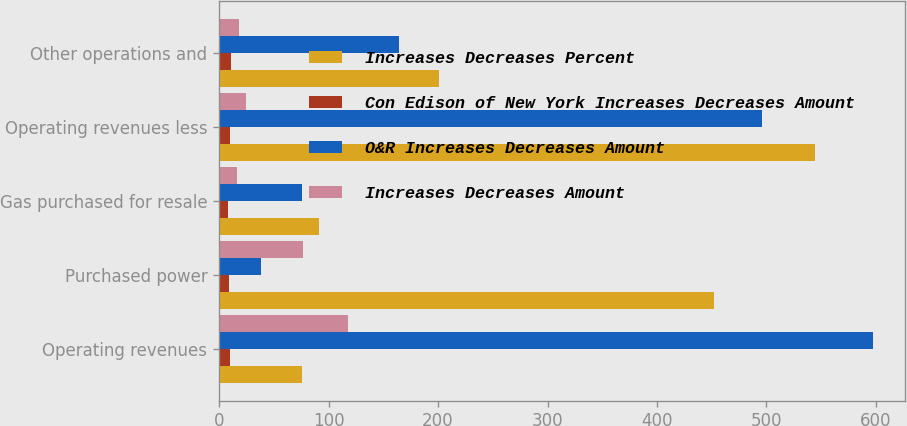<chart> <loc_0><loc_0><loc_500><loc_500><stacked_bar_chart><ecel><fcel>Operating revenues<fcel>Purchased power<fcel>Gas purchased for resale<fcel>Operating revenues less<fcel>Other operations and<nl><fcel>Increases Decreases Percent<fcel>76<fcel>452<fcel>91<fcel>544<fcel>201<nl><fcel>Con Edison of New York Increases Decreases Amount<fcel>9.7<fcel>9.1<fcel>8.4<fcel>10.2<fcel>10.7<nl><fcel>O&R Increases Decreases Amount<fcel>597<fcel>38<fcel>76<fcel>496<fcel>164<nl><fcel>Increases Decreases Amount<fcel>118<fcel>77<fcel>16<fcel>25<fcel>18<nl></chart> 